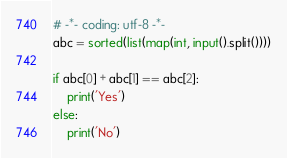<code> <loc_0><loc_0><loc_500><loc_500><_Python_># -*- coding: utf-8 -*-
abc = sorted(list(map(int, input().split())))

if abc[0] + abc[1] == abc[2]:
    print('Yes')
else:
    print('No')
</code> 